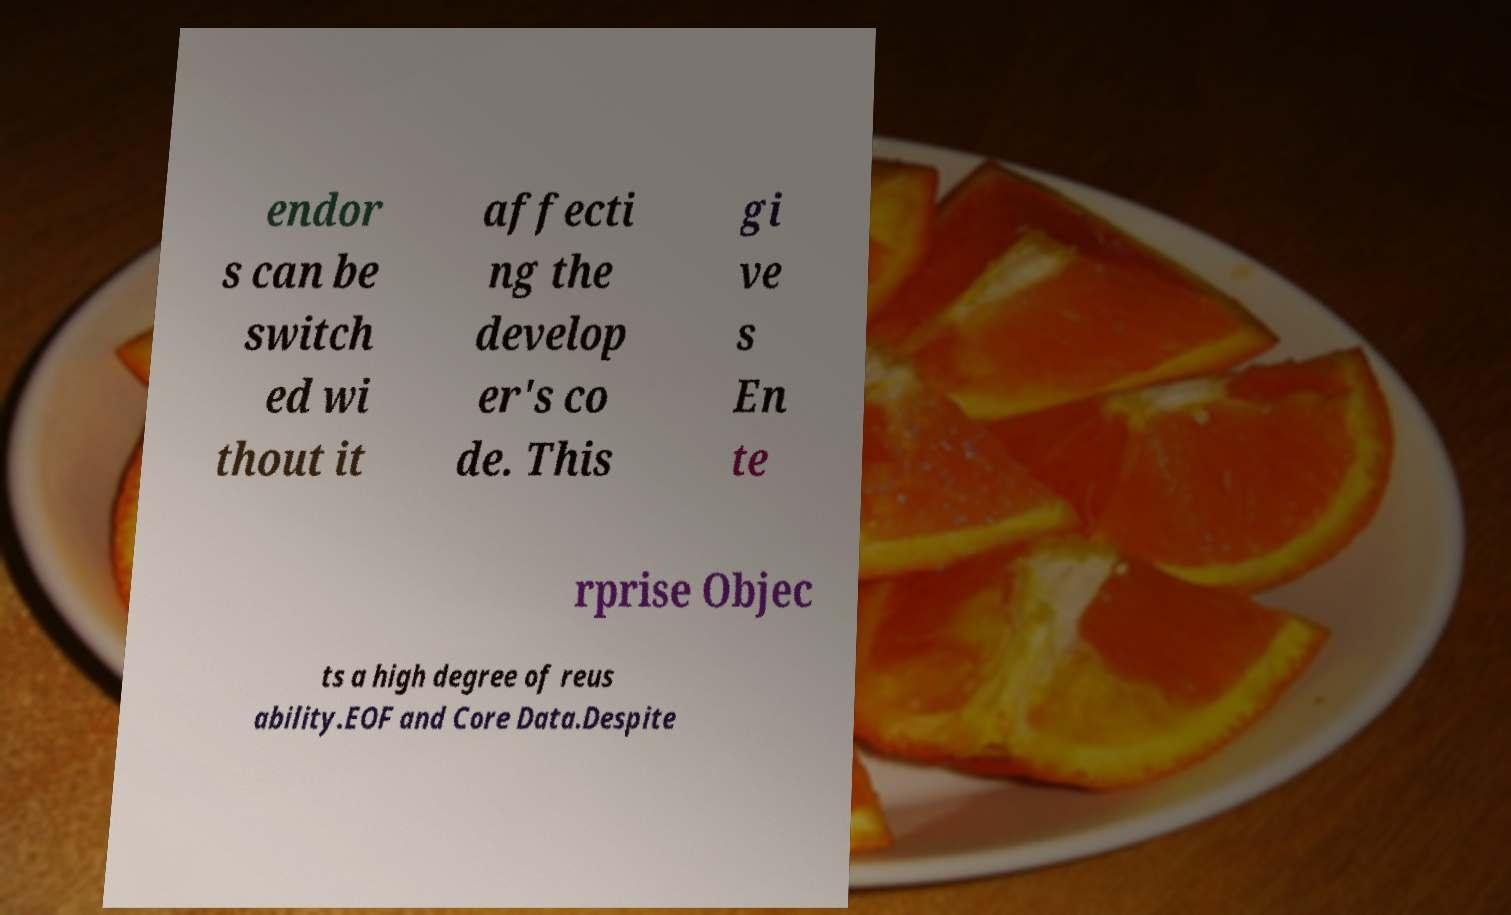Can you read and provide the text displayed in the image?This photo seems to have some interesting text. Can you extract and type it out for me? endor s can be switch ed wi thout it affecti ng the develop er's co de. This gi ve s En te rprise Objec ts a high degree of reus ability.EOF and Core Data.Despite 